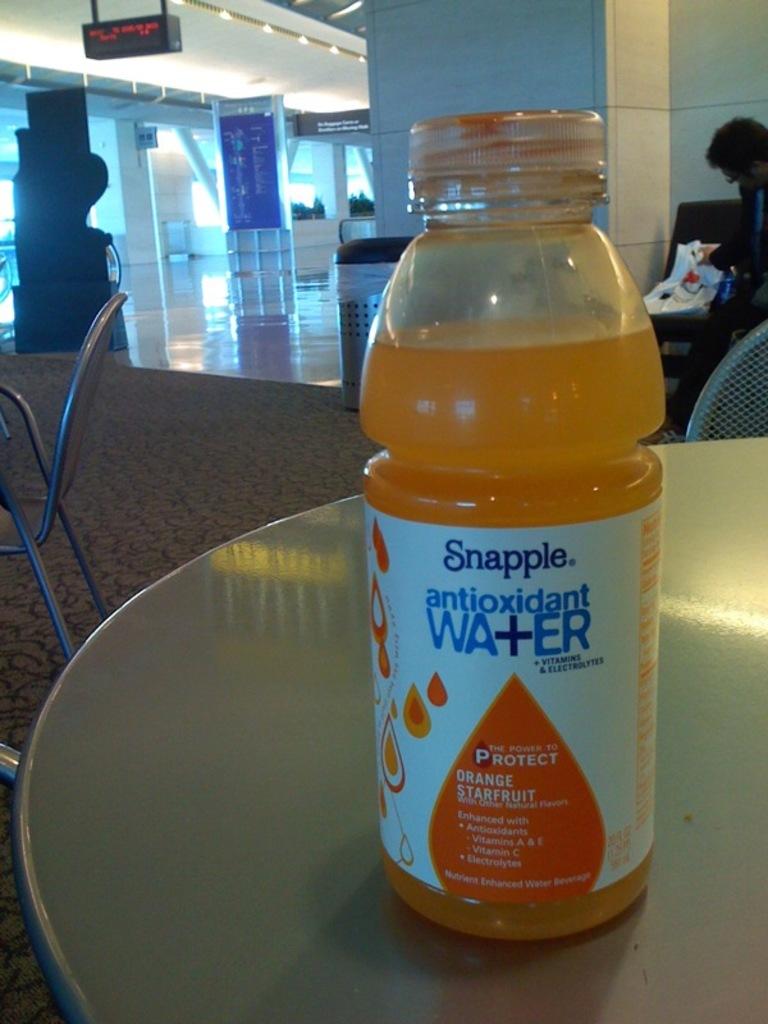What kind of water is this?
Ensure brevity in your answer.  Antioxidant. 